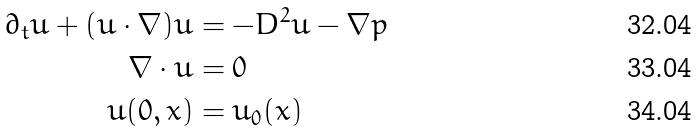Convert formula to latex. <formula><loc_0><loc_0><loc_500><loc_500>\partial _ { t } u + ( u \cdot \nabla ) u & = - D ^ { 2 } u - \nabla p \\ \nabla \cdot u & = 0 \\ u ( 0 , x ) & = u _ { 0 } ( x )</formula> 